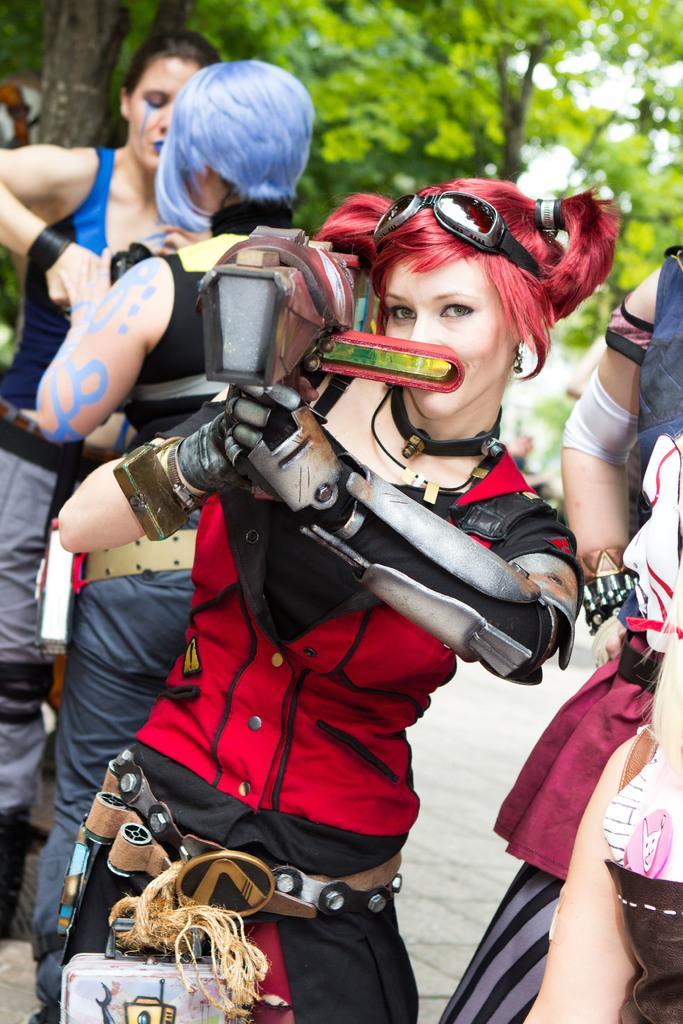What can be seen in the image? There is a group of women in the image. What are the women wearing? The women are dressed in different cosplays. Where are the women located? The women are present over a place. What can be seen in the background of the image? There are plants and trees in the background of the image. What type of carriage can be seen in the image? There is no carriage present in the image. What is the temper of the women in the image? The image does not provide information about the temper of the women. 